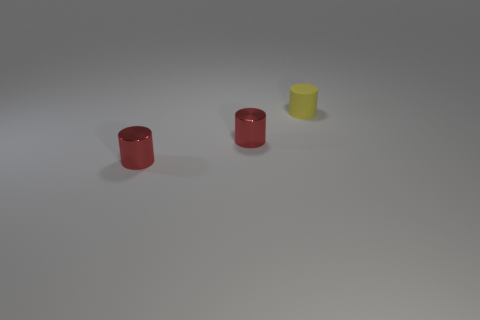How is the lighting in the image affecting the appearance of these objects? The lighting in the image is soft and diffused, creating subtle shadows and highlights on the objects. This lighting emphasizes the shiny texture of the red objects, which reflect more light and appear more luminous, while the matte yellow object absorbs more light, giving it a flatter appearance. 